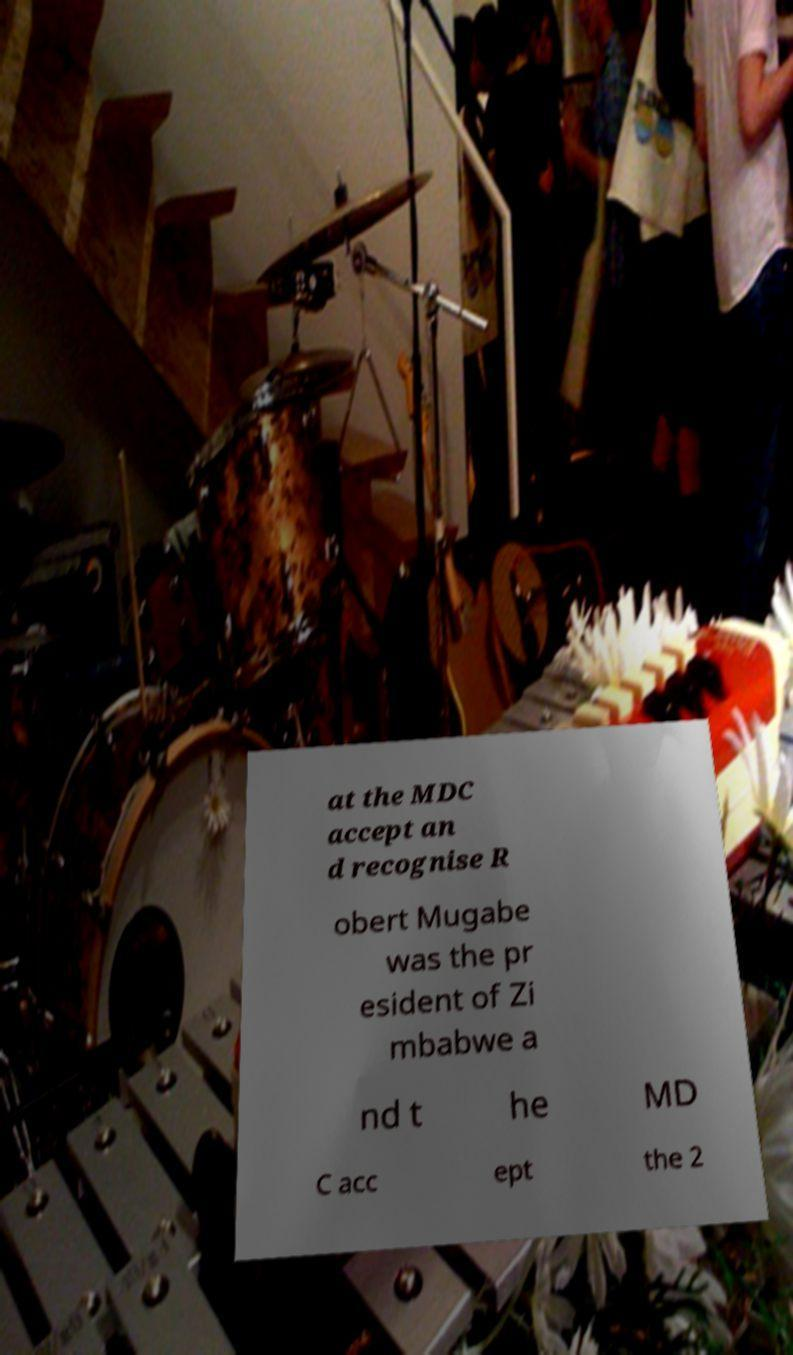I need the written content from this picture converted into text. Can you do that? at the MDC accept an d recognise R obert Mugabe was the pr esident of Zi mbabwe a nd t he MD C acc ept the 2 